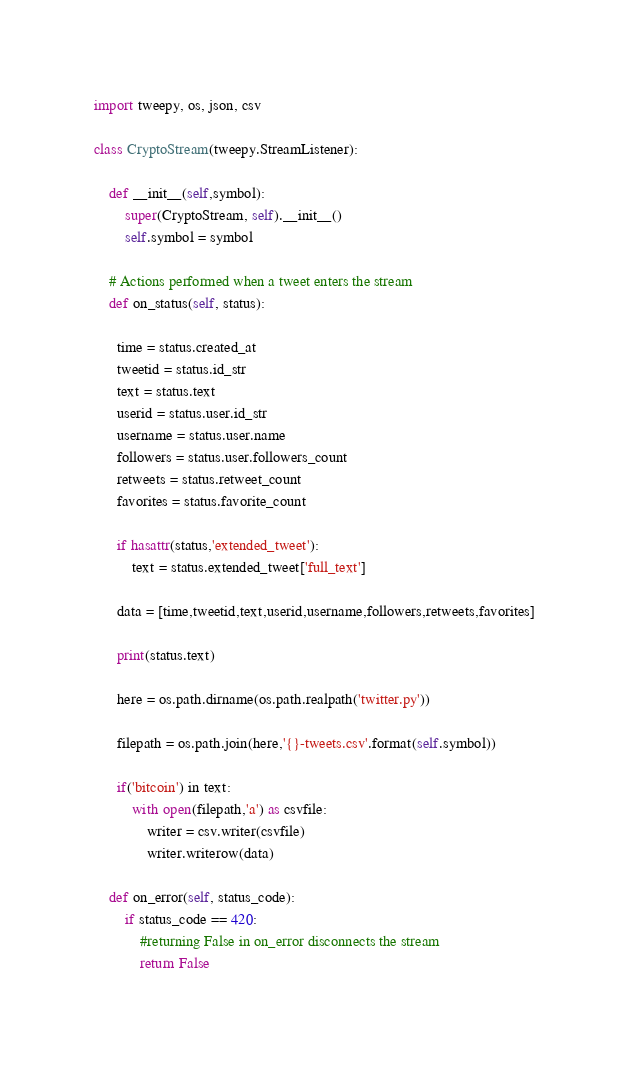<code> <loc_0><loc_0><loc_500><loc_500><_Python_>import tweepy, os, json, csv

class CryptoStream(tweepy.StreamListener):

    def __init__(self,symbol):
        super(CryptoStream, self).__init__()
        self.symbol = symbol
        
    # Actions performed when a tweet enters the stream
    def on_status(self, status):
       
      time = status.created_at
      tweetid = status.id_str
      text = status.text
      userid = status.user.id_str
      username = status.user.name
      followers = status.user.followers_count
      retweets = status.retweet_count
      favorites = status.favorite_count
      
      if hasattr(status,'extended_tweet'):
          text = status.extended_tweet['full_text']
          
      data = [time,tweetid,text,userid,username,followers,retweets,favorites]
      
      print(status.text)
      
      here = os.path.dirname(os.path.realpath('twitter.py'))
      
      filepath = os.path.join(here,'{}-tweets.csv'.format(self.symbol))
      
      if('bitcoin') in text:
          with open(filepath,'a') as csvfile:
              writer = csv.writer(csvfile)
              writer.writerow(data)
        
    def on_error(self, status_code):
        if status_code == 420:
            #returning False in on_error disconnects the stream
            return False
        </code> 